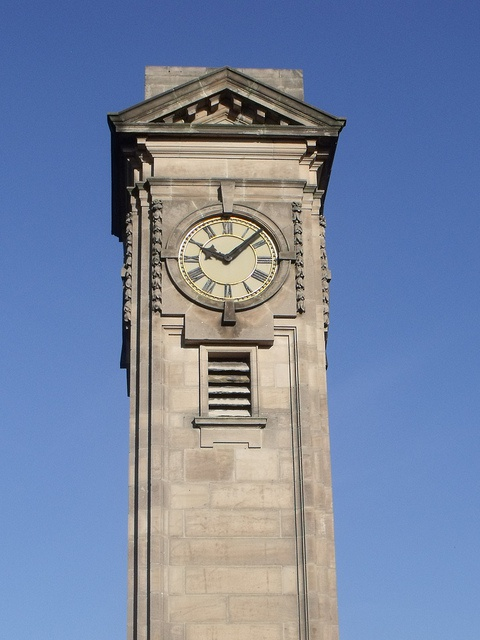Describe the objects in this image and their specific colors. I can see a clock in blue, tan, gray, darkgray, and beige tones in this image. 